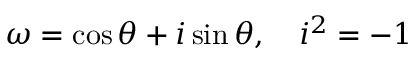<formula> <loc_0><loc_0><loc_500><loc_500>\ \omega = \cos \theta + i \sin \theta , \quad i ^ { 2 } = - 1</formula> 